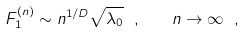<formula> <loc_0><loc_0><loc_500><loc_500>F ^ { ( n ) } _ { 1 } \sim n ^ { 1 / D } \sqrt { \lambda _ { 0 } } \ , \quad n \to \infty \ ,</formula> 